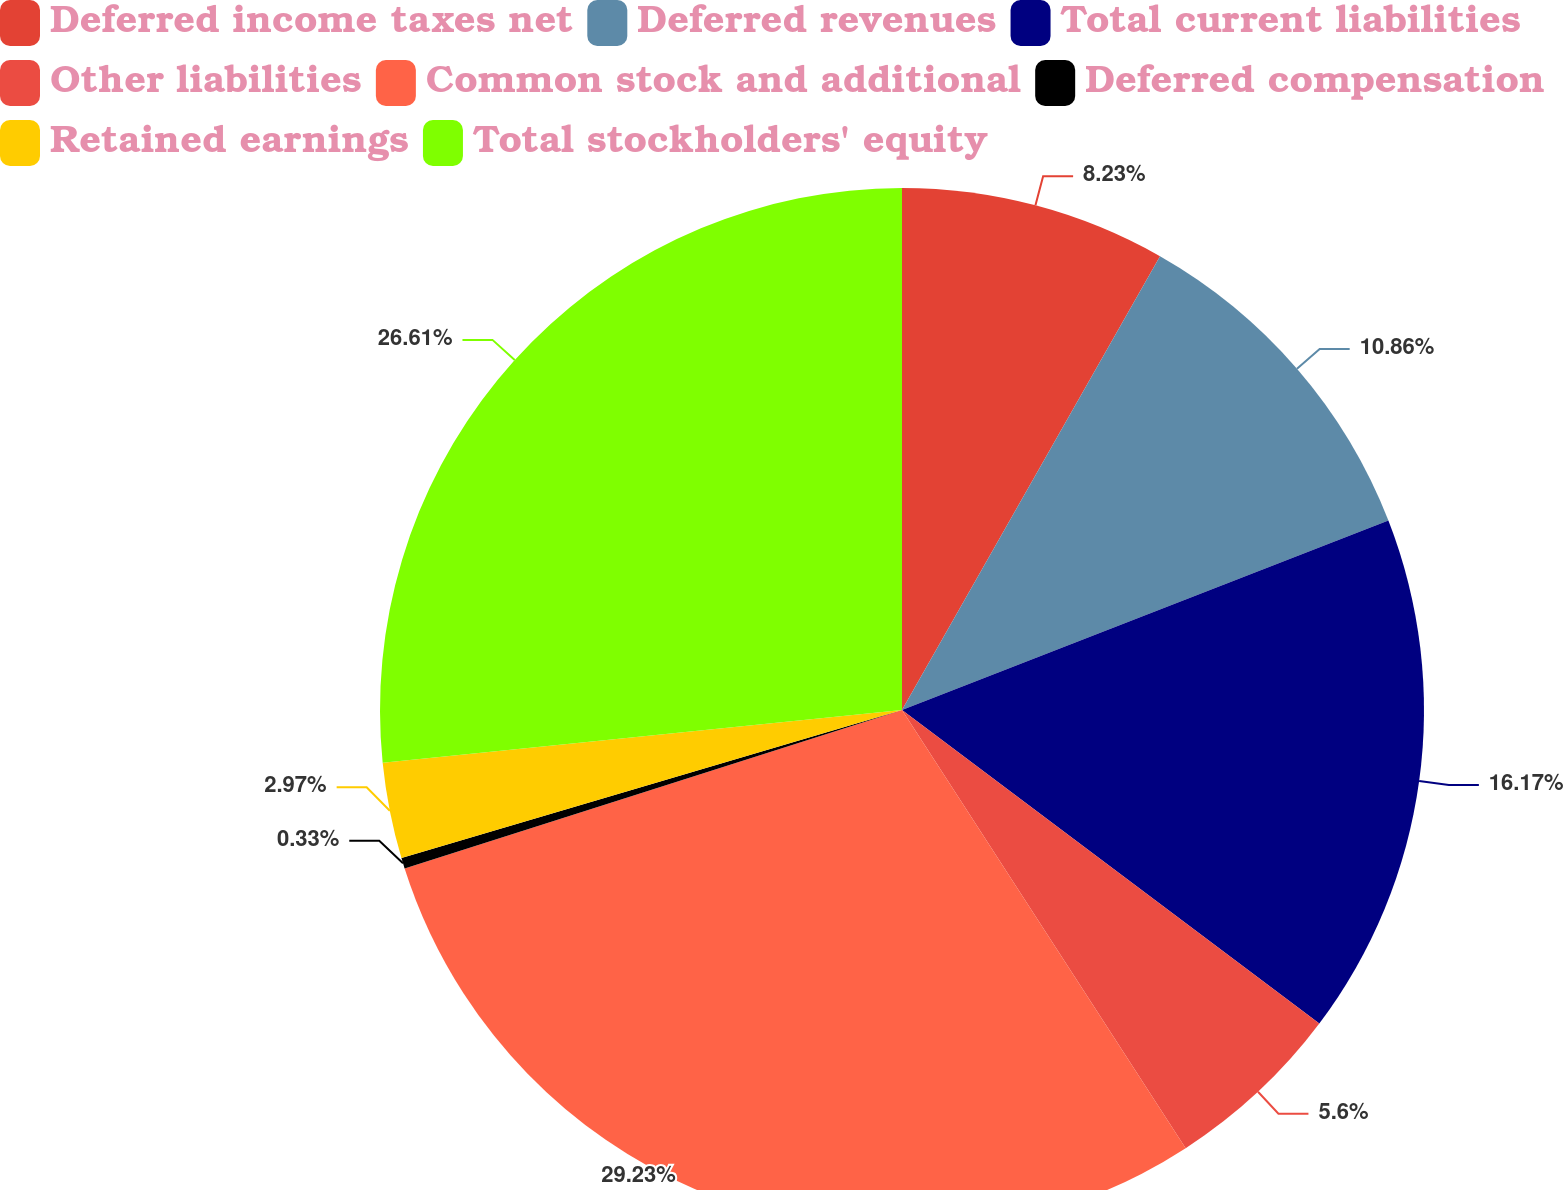Convert chart. <chart><loc_0><loc_0><loc_500><loc_500><pie_chart><fcel>Deferred income taxes net<fcel>Deferred revenues<fcel>Total current liabilities<fcel>Other liabilities<fcel>Common stock and additional<fcel>Deferred compensation<fcel>Retained earnings<fcel>Total stockholders' equity<nl><fcel>8.23%<fcel>10.86%<fcel>16.17%<fcel>5.6%<fcel>29.24%<fcel>0.33%<fcel>2.97%<fcel>26.61%<nl></chart> 